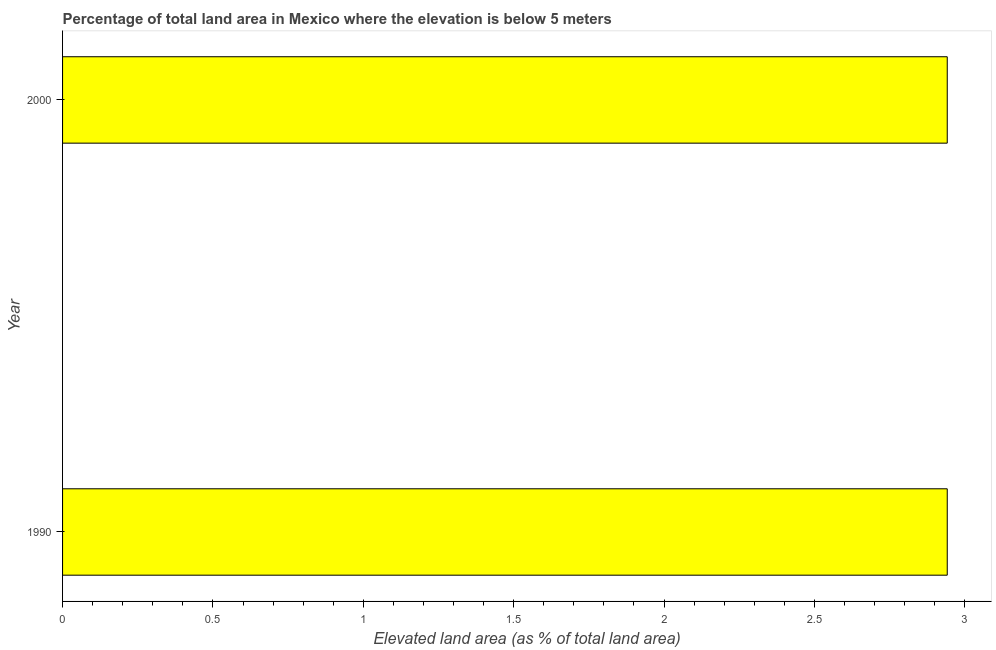Does the graph contain grids?
Your response must be concise. No. What is the title of the graph?
Give a very brief answer. Percentage of total land area in Mexico where the elevation is below 5 meters. What is the label or title of the X-axis?
Your answer should be compact. Elevated land area (as % of total land area). What is the total elevated land area in 1990?
Offer a terse response. 2.94. Across all years, what is the maximum total elevated land area?
Provide a short and direct response. 2.94. Across all years, what is the minimum total elevated land area?
Offer a very short reply. 2.94. What is the sum of the total elevated land area?
Offer a very short reply. 5.88. What is the average total elevated land area per year?
Provide a succinct answer. 2.94. What is the median total elevated land area?
Keep it short and to the point. 2.94. What is the ratio of the total elevated land area in 1990 to that in 2000?
Keep it short and to the point. 1. Is the total elevated land area in 1990 less than that in 2000?
Your answer should be very brief. No. How many bars are there?
Your response must be concise. 2. How many years are there in the graph?
Your answer should be compact. 2. Are the values on the major ticks of X-axis written in scientific E-notation?
Ensure brevity in your answer.  No. What is the Elevated land area (as % of total land area) in 1990?
Provide a succinct answer. 2.94. What is the Elevated land area (as % of total land area) of 2000?
Provide a short and direct response. 2.94. What is the ratio of the Elevated land area (as % of total land area) in 1990 to that in 2000?
Keep it short and to the point. 1. 